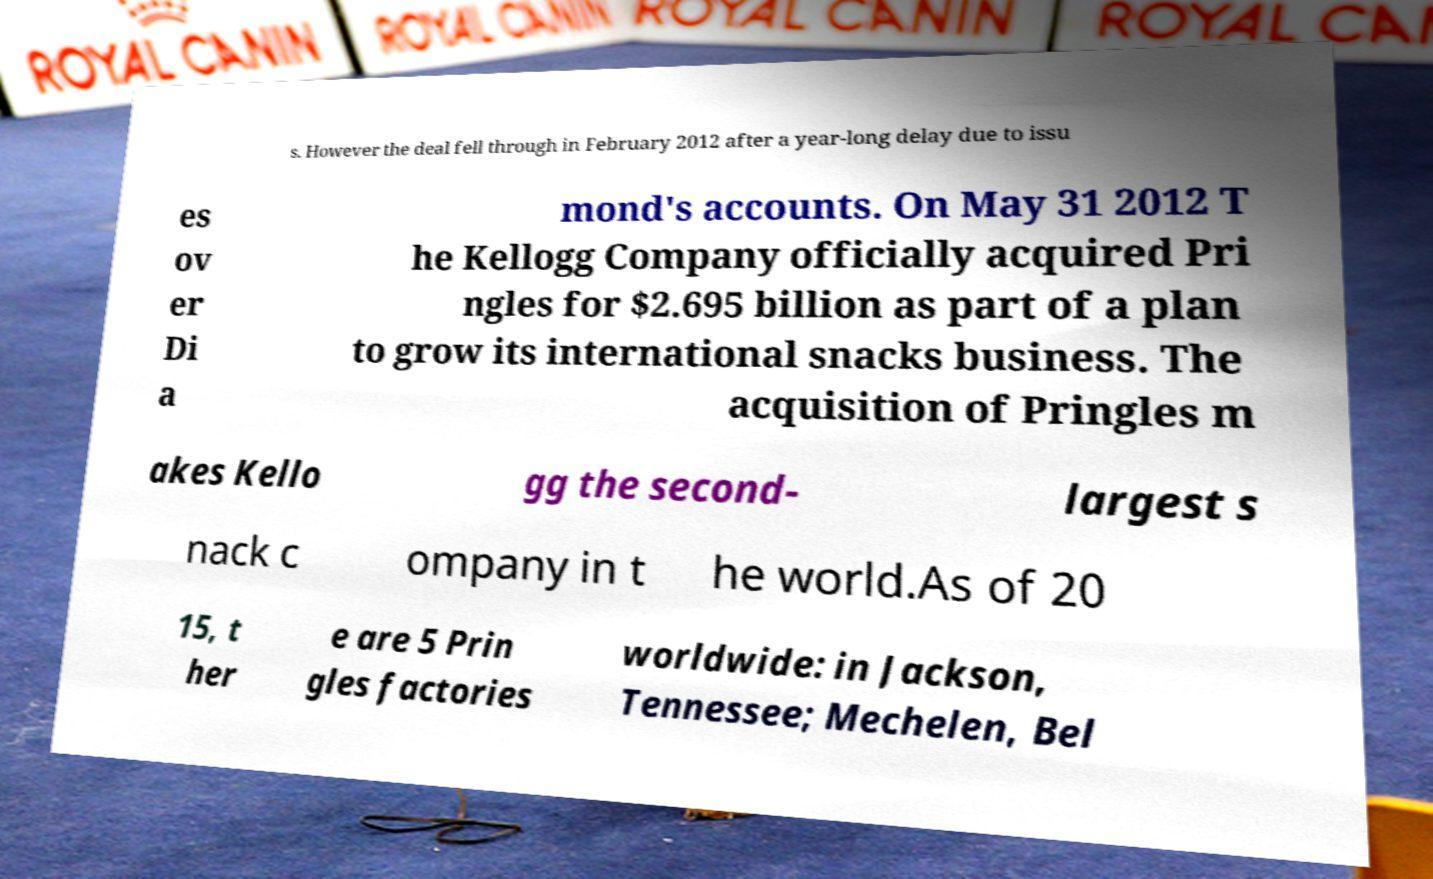I need the written content from this picture converted into text. Can you do that? s. However the deal fell through in February 2012 after a year-long delay due to issu es ov er Di a mond's accounts. On May 31 2012 T he Kellogg Company officially acquired Pri ngles for $2.695 billion as part of a plan to grow its international snacks business. The acquisition of Pringles m akes Kello gg the second- largest s nack c ompany in t he world.As of 20 15, t her e are 5 Prin gles factories worldwide: in Jackson, Tennessee; Mechelen, Bel 